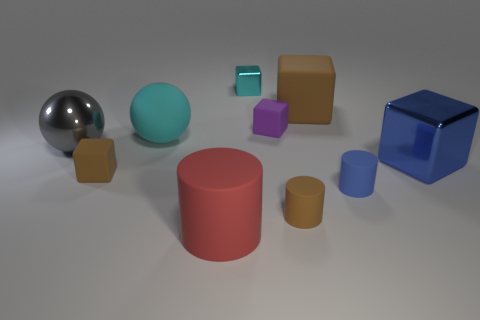Subtract all blue cubes. How many cubes are left? 4 Subtract all cyan blocks. How many blocks are left? 4 Subtract all gray blocks. Subtract all brown spheres. How many blocks are left? 5 Subtract all balls. How many objects are left? 8 Subtract all large green shiny spheres. Subtract all large brown blocks. How many objects are left? 9 Add 1 brown cylinders. How many brown cylinders are left? 2 Add 7 large blue rubber spheres. How many large blue rubber spheres exist? 7 Subtract 0 red blocks. How many objects are left? 10 